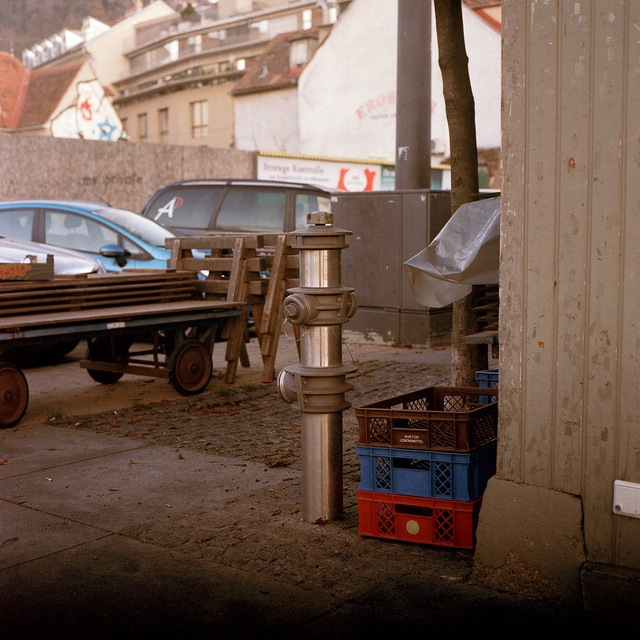Describe the objects in this image and their specific colors. I can see fire hydrant in gray, maroon, and black tones, car in gray and maroon tones, car in gray, darkgray, and lavender tones, and car in gray, lavender, darkgray, and maroon tones in this image. 